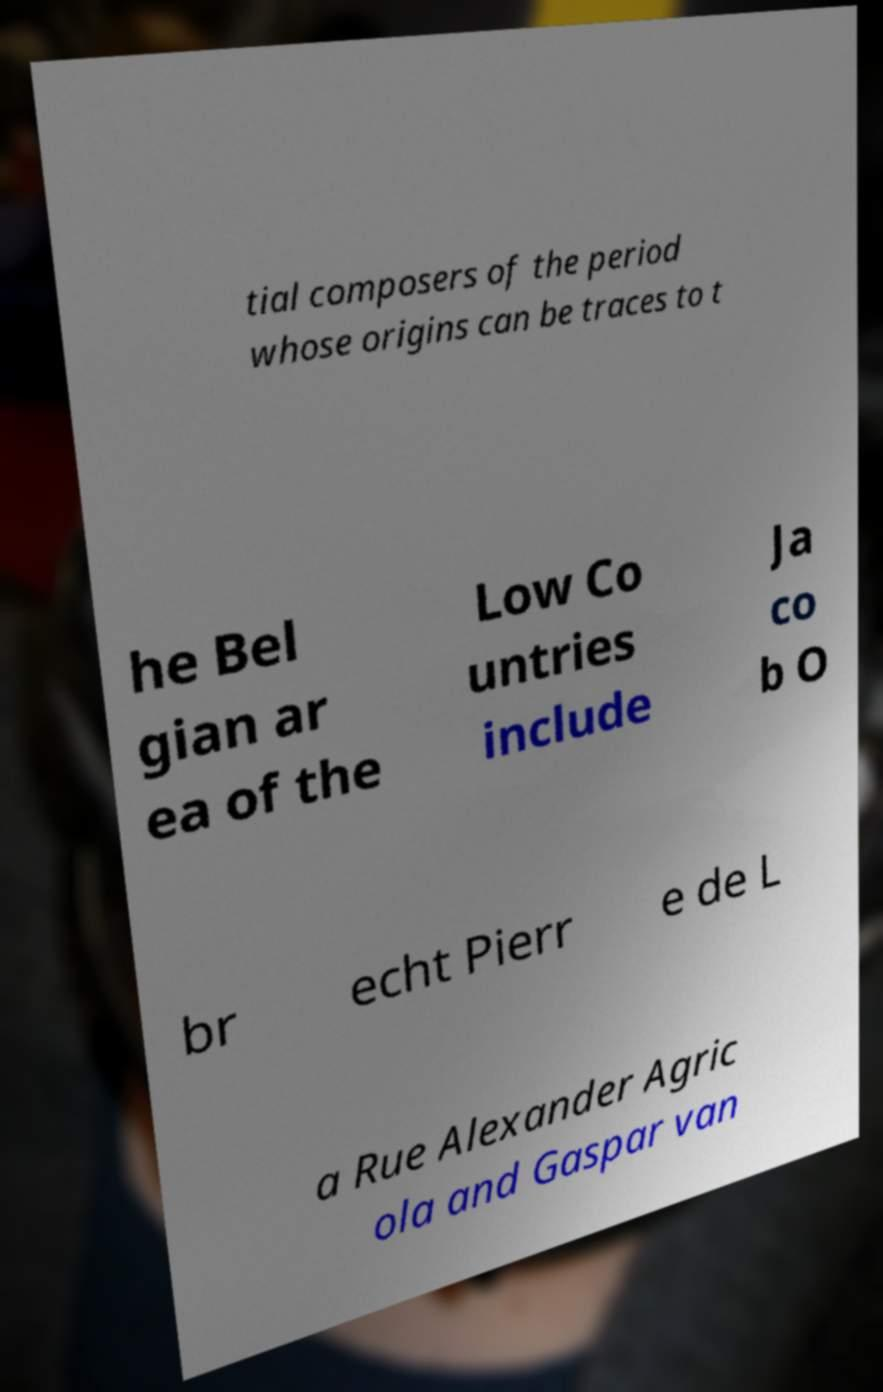Could you assist in decoding the text presented in this image and type it out clearly? tial composers of the period whose origins can be traces to t he Bel gian ar ea of the Low Co untries include Ja co b O br echt Pierr e de L a Rue Alexander Agric ola and Gaspar van 